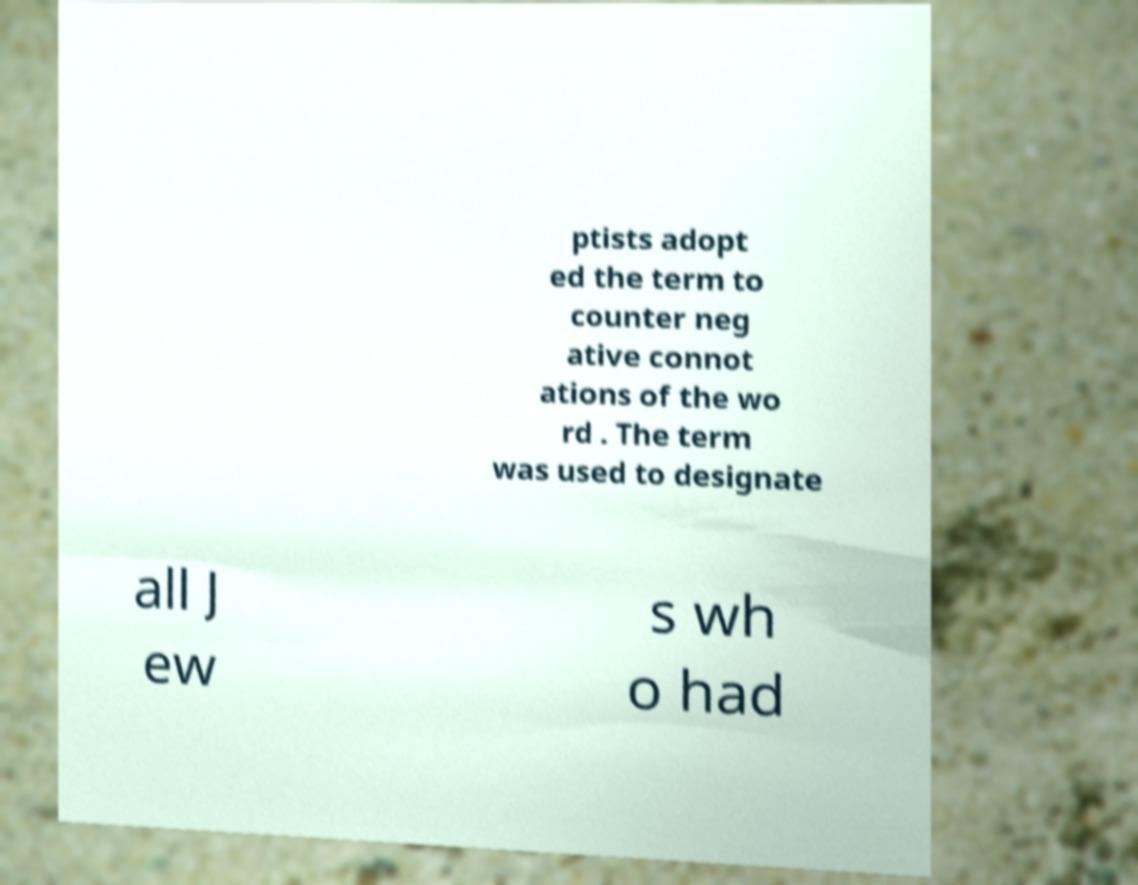Please read and relay the text visible in this image. What does it say? ptists adopt ed the term to counter neg ative connot ations of the wo rd . The term was used to designate all J ew s wh o had 